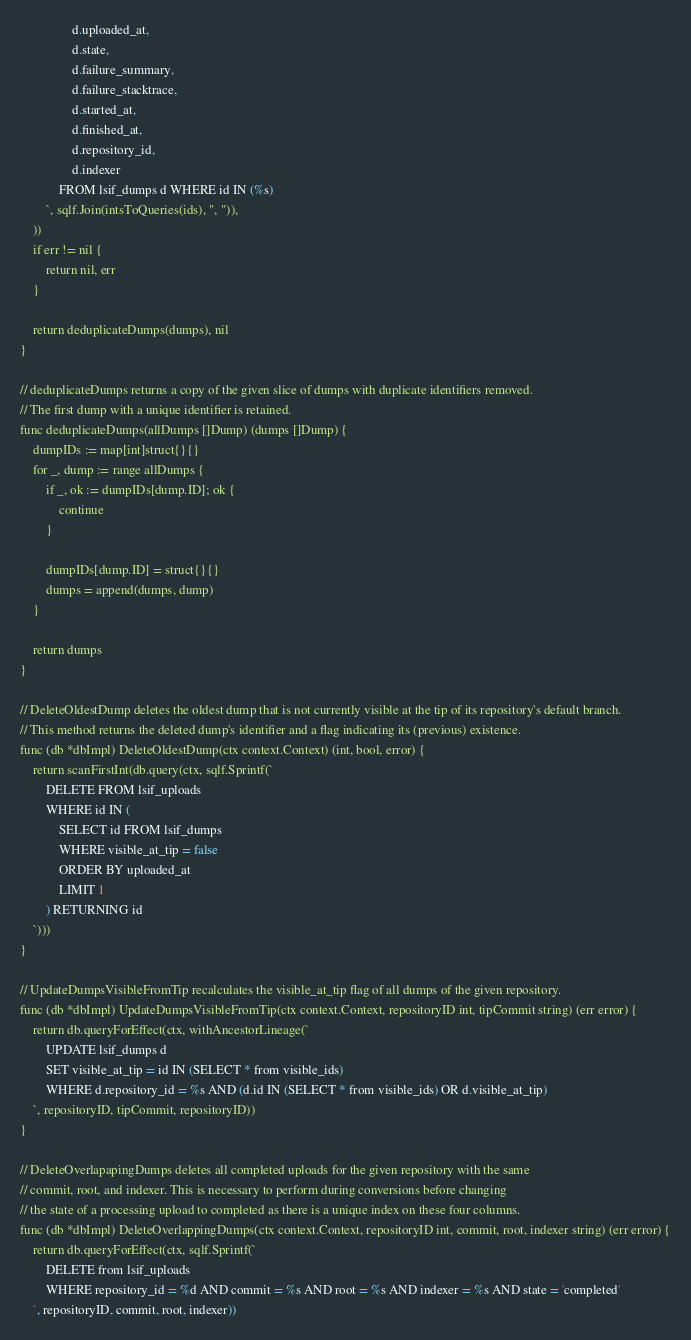Convert code to text. <code><loc_0><loc_0><loc_500><loc_500><_Go_>				d.uploaded_at,
				d.state,
				d.failure_summary,
				d.failure_stacktrace,
				d.started_at,
				d.finished_at,
				d.repository_id,
				d.indexer
			FROM lsif_dumps d WHERE id IN (%s)
		`, sqlf.Join(intsToQueries(ids), ", ")),
	))
	if err != nil {
		return nil, err
	}

	return deduplicateDumps(dumps), nil
}

// deduplicateDumps returns a copy of the given slice of dumps with duplicate identifiers removed.
// The first dump with a unique identifier is retained.
func deduplicateDumps(allDumps []Dump) (dumps []Dump) {
	dumpIDs := map[int]struct{}{}
	for _, dump := range allDumps {
		if _, ok := dumpIDs[dump.ID]; ok {
			continue
		}

		dumpIDs[dump.ID] = struct{}{}
		dumps = append(dumps, dump)
	}

	return dumps
}

// DeleteOldestDump deletes the oldest dump that is not currently visible at the tip of its repository's default branch.
// This method returns the deleted dump's identifier and a flag indicating its (previous) existence.
func (db *dbImpl) DeleteOldestDump(ctx context.Context) (int, bool, error) {
	return scanFirstInt(db.query(ctx, sqlf.Sprintf(`
		DELETE FROM lsif_uploads
		WHERE id IN (
			SELECT id FROM lsif_dumps
			WHERE visible_at_tip = false
			ORDER BY uploaded_at
			LIMIT 1
		) RETURNING id
	`)))
}

// UpdateDumpsVisibleFromTip recalculates the visible_at_tip flag of all dumps of the given repository.
func (db *dbImpl) UpdateDumpsVisibleFromTip(ctx context.Context, repositoryID int, tipCommit string) (err error) {
	return db.queryForEffect(ctx, withAncestorLineage(`
		UPDATE lsif_dumps d
		SET visible_at_tip = id IN (SELECT * from visible_ids)
		WHERE d.repository_id = %s AND (d.id IN (SELECT * from visible_ids) OR d.visible_at_tip)
	`, repositoryID, tipCommit, repositoryID))
}

// DeleteOverlapapingDumps deletes all completed uploads for the given repository with the same
// commit, root, and indexer. This is necessary to perform during conversions before changing
// the state of a processing upload to completed as there is a unique index on these four columns.
func (db *dbImpl) DeleteOverlappingDumps(ctx context.Context, repositoryID int, commit, root, indexer string) (err error) {
	return db.queryForEffect(ctx, sqlf.Sprintf(`
		DELETE from lsif_uploads
		WHERE repository_id = %d AND commit = %s AND root = %s AND indexer = %s AND state = 'completed'
	`, repositoryID, commit, root, indexer))</code> 